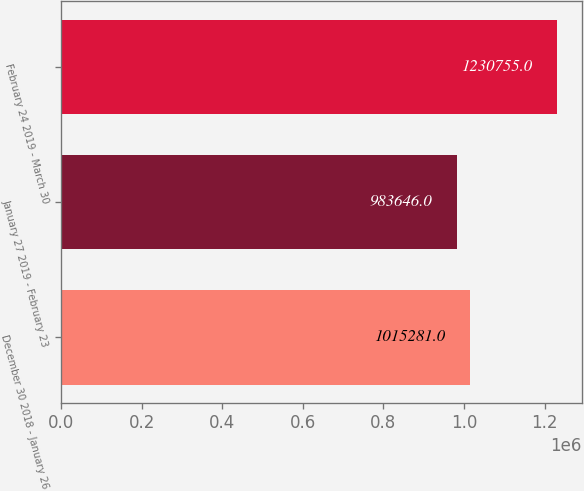Convert chart to OTSL. <chart><loc_0><loc_0><loc_500><loc_500><bar_chart><fcel>December 30 2018 - January 26<fcel>January 27 2019 - February 23<fcel>February 24 2019 - March 30<nl><fcel>1.01528e+06<fcel>983646<fcel>1.23076e+06<nl></chart> 